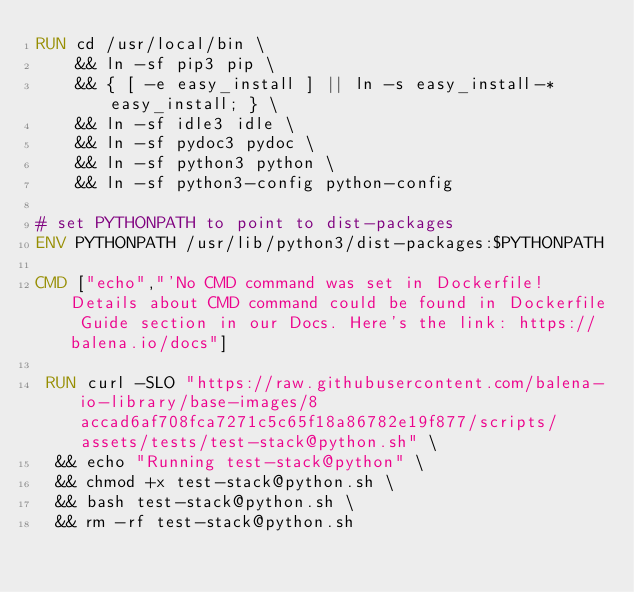<code> <loc_0><loc_0><loc_500><loc_500><_Dockerfile_>RUN cd /usr/local/bin \
	&& ln -sf pip3 pip \
	&& { [ -e easy_install ] || ln -s easy_install-* easy_install; } \
	&& ln -sf idle3 idle \
	&& ln -sf pydoc3 pydoc \
	&& ln -sf python3 python \
	&& ln -sf python3-config python-config

# set PYTHONPATH to point to dist-packages
ENV PYTHONPATH /usr/lib/python3/dist-packages:$PYTHONPATH

CMD ["echo","'No CMD command was set in Dockerfile! Details about CMD command could be found in Dockerfile Guide section in our Docs. Here's the link: https://balena.io/docs"]

 RUN curl -SLO "https://raw.githubusercontent.com/balena-io-library/base-images/8accad6af708fca7271c5c65f18a86782e19f877/scripts/assets/tests/test-stack@python.sh" \
  && echo "Running test-stack@python" \
  && chmod +x test-stack@python.sh \
  && bash test-stack@python.sh \
  && rm -rf test-stack@python.sh 
</code> 